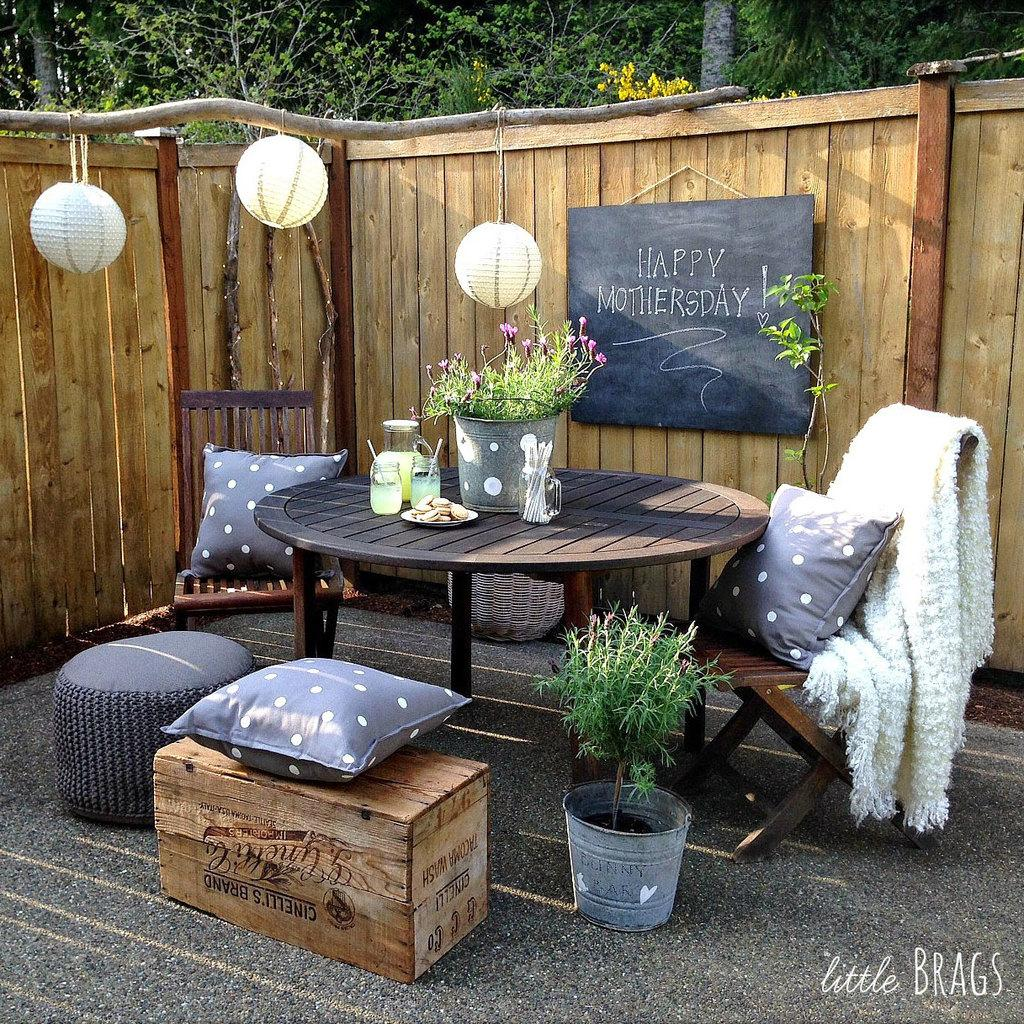What type of outdoor space is visible in the image? There is a balcony in the image. What furniture is present on the balcony? The balcony has a table and cushions. Are there any lighting fixtures on the balcony? Yes, the balcony has lights. What type of greenery is on the balcony? There is a plant on the balcony. What can be seen in the background of the image? Trees are visible in the image. What type of debt is being discussed on the balcony in the image? There is no mention of debt in the image; it features a balcony with a table, cushions, lights, and a plant. Is there a gate visible in the image? No, there is no gate visible in the image. 